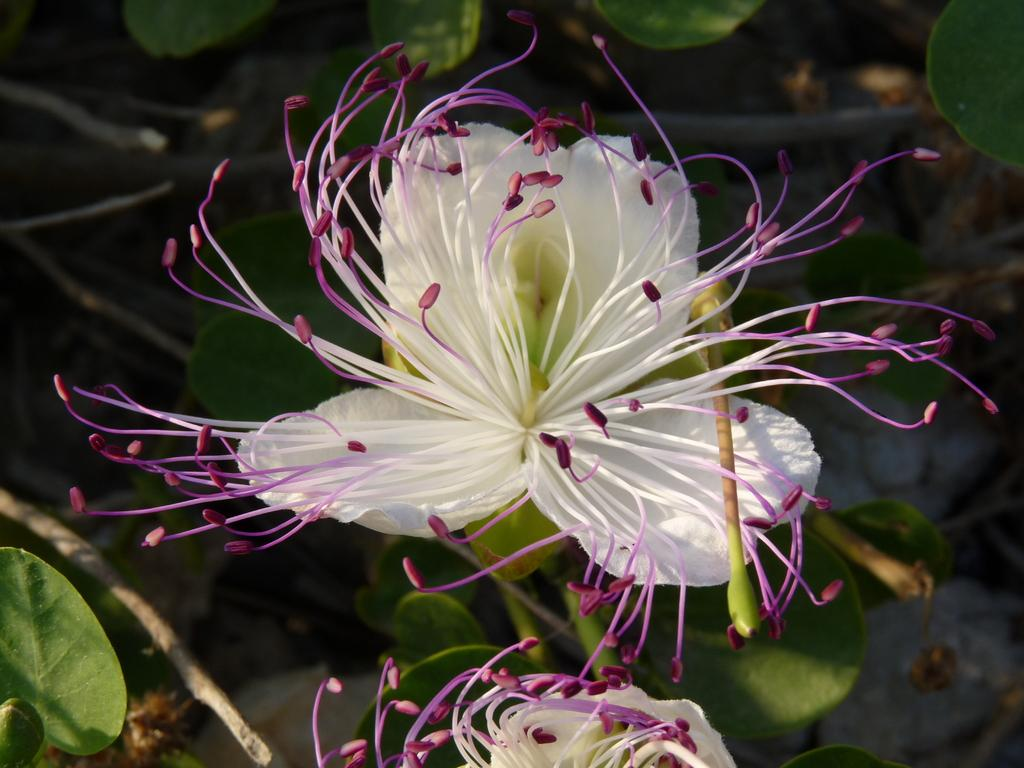What type of plants can be seen in the image? There are flowers in the image. What else can be seen in the background of the image? There are leaves in the background of the image. What type of cart is used to transport the flowers in the image? There is no cart present in the image; it only features flowers and leaves. 